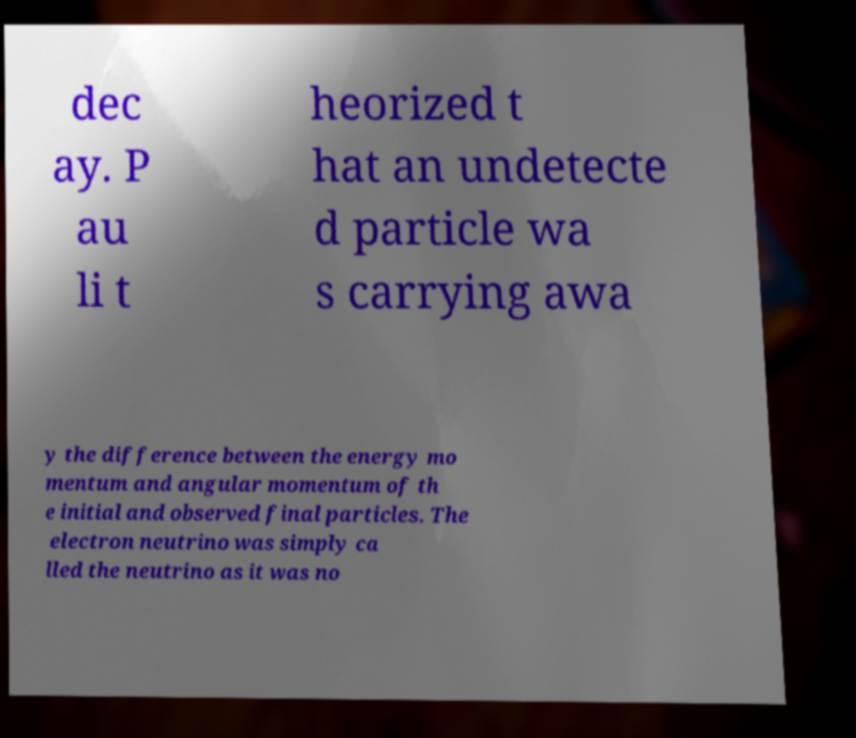Can you accurately transcribe the text from the provided image for me? dec ay. P au li t heorized t hat an undetecte d particle wa s carrying awa y the difference between the energy mo mentum and angular momentum of th e initial and observed final particles. The electron neutrino was simply ca lled the neutrino as it was no 